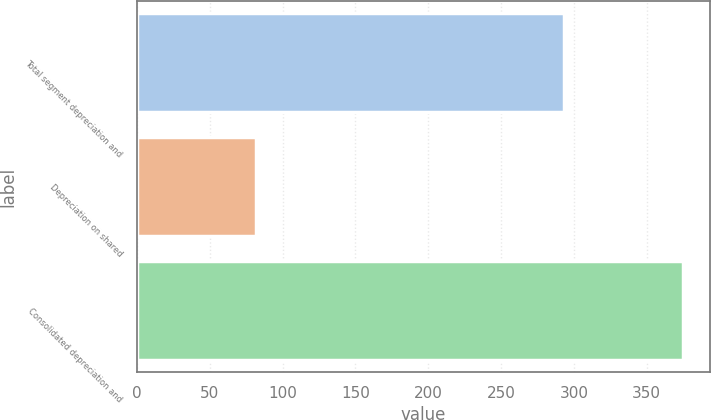Convert chart to OTSL. <chart><loc_0><loc_0><loc_500><loc_500><bar_chart><fcel>Total segment depreciation and<fcel>Depreciation on shared<fcel>Consolidated depreciation and<nl><fcel>293<fcel>82<fcel>375<nl></chart> 